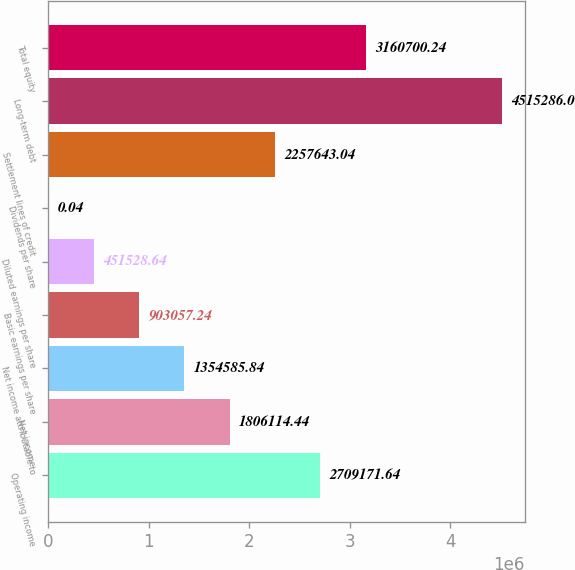Convert chart to OTSL. <chart><loc_0><loc_0><loc_500><loc_500><bar_chart><fcel>Operating income<fcel>Net income<fcel>Net income attributable to<fcel>Basic earnings per share<fcel>Diluted earnings per share<fcel>Dividends per share<fcel>Settlement lines of credit<fcel>Long-term debt<fcel>Total equity<nl><fcel>2.70917e+06<fcel>1.80611e+06<fcel>1.35459e+06<fcel>903057<fcel>451529<fcel>0.04<fcel>2.25764e+06<fcel>4.51529e+06<fcel>3.1607e+06<nl></chart> 